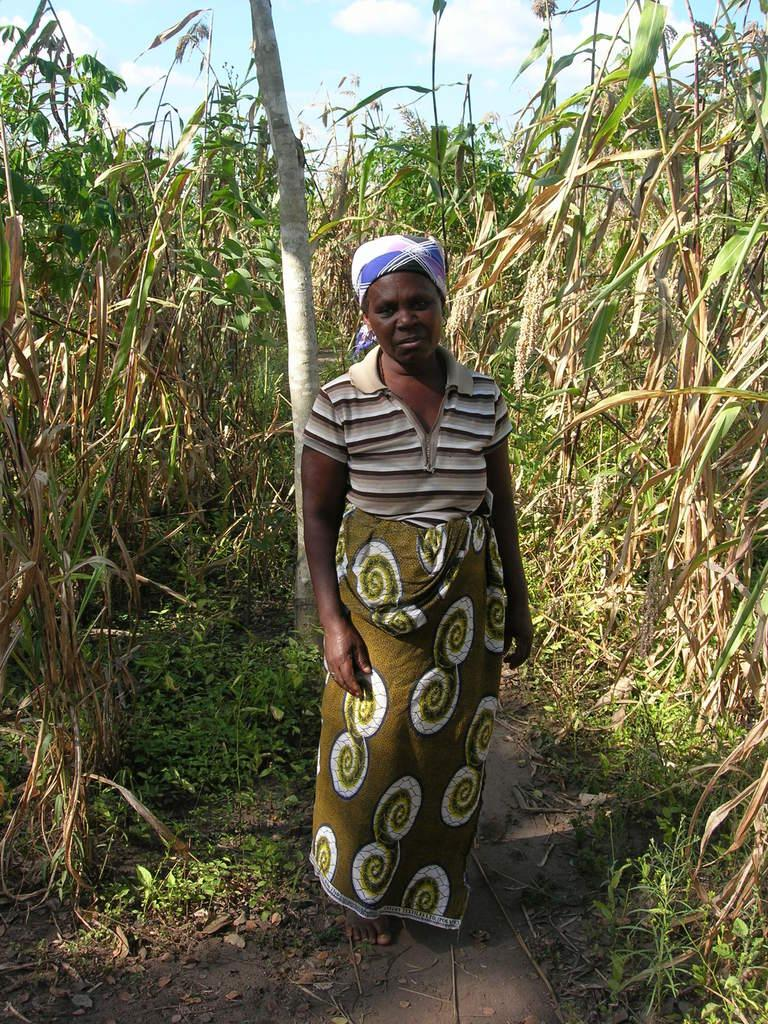What is the main subject of the image? There is a person standing in the image. What can be seen behind the person? There are plants behind the person. What type of drain is visible in the image? There is no drain present in the image. What effect does the person standing have on the plants behind them? The person standing does not have any visible effect on the plants in the image. 